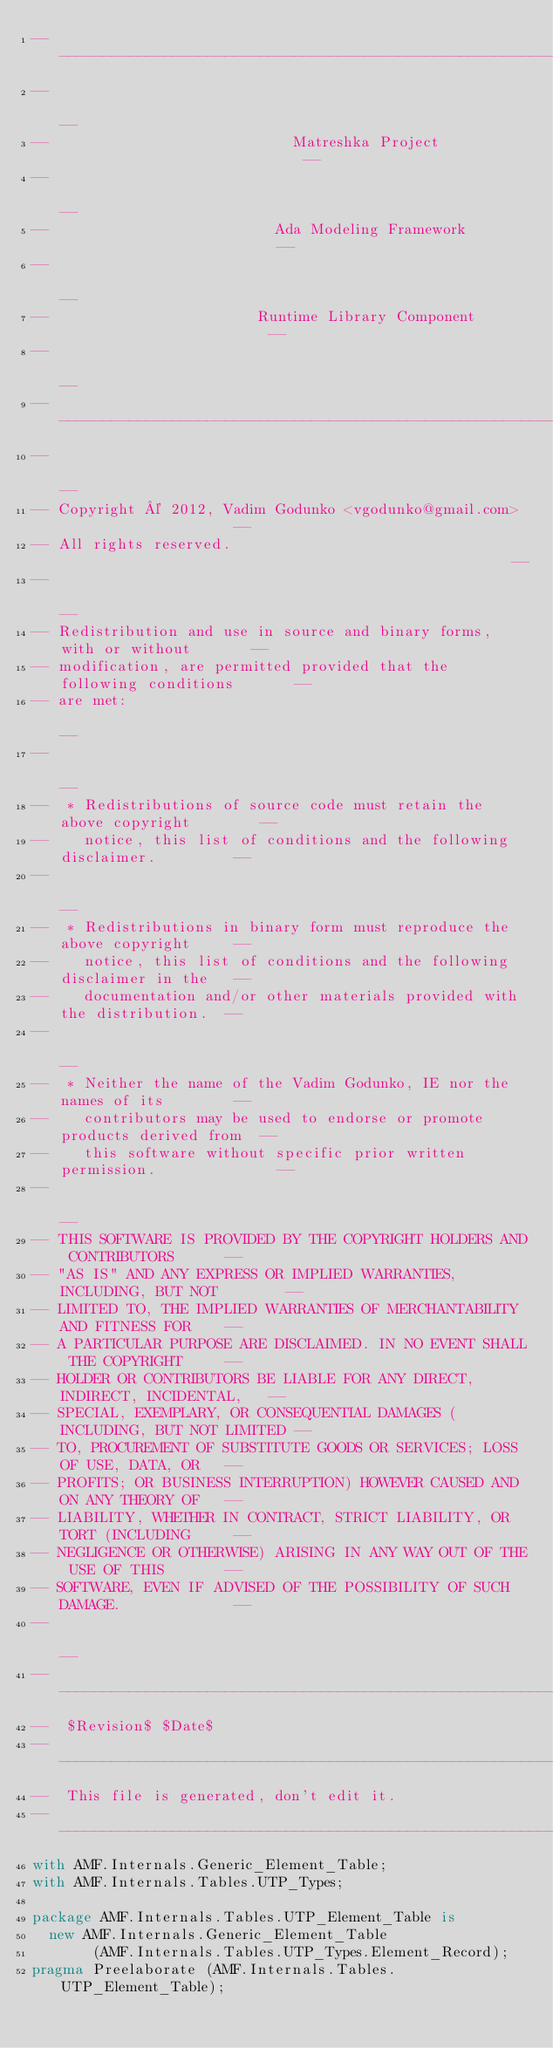Convert code to text. <code><loc_0><loc_0><loc_500><loc_500><_Ada_>------------------------------------------------------------------------------
--                                                                          --
--                            Matreshka Project                             --
--                                                                          --
--                          Ada Modeling Framework                          --
--                                                                          --
--                        Runtime Library Component                         --
--                                                                          --
------------------------------------------------------------------------------
--                                                                          --
-- Copyright © 2012, Vadim Godunko <vgodunko@gmail.com>                     --
-- All rights reserved.                                                     --
--                                                                          --
-- Redistribution and use in source and binary forms, with or without       --
-- modification, are permitted provided that the following conditions       --
-- are met:                                                                 --
--                                                                          --
--  * Redistributions of source code must retain the above copyright        --
--    notice, this list of conditions and the following disclaimer.         --
--                                                                          --
--  * Redistributions in binary form must reproduce the above copyright     --
--    notice, this list of conditions and the following disclaimer in the   --
--    documentation and/or other materials provided with the distribution.  --
--                                                                          --
--  * Neither the name of the Vadim Godunko, IE nor the names of its        --
--    contributors may be used to endorse or promote products derived from  --
--    this software without specific prior written permission.              --
--                                                                          --
-- THIS SOFTWARE IS PROVIDED BY THE COPYRIGHT HOLDERS AND CONTRIBUTORS      --
-- "AS IS" AND ANY EXPRESS OR IMPLIED WARRANTIES, INCLUDING, BUT NOT        --
-- LIMITED TO, THE IMPLIED WARRANTIES OF MERCHANTABILITY AND FITNESS FOR    --
-- A PARTICULAR PURPOSE ARE DISCLAIMED. IN NO EVENT SHALL THE COPYRIGHT     --
-- HOLDER OR CONTRIBUTORS BE LIABLE FOR ANY DIRECT, INDIRECT, INCIDENTAL,   --
-- SPECIAL, EXEMPLARY, OR CONSEQUENTIAL DAMAGES (INCLUDING, BUT NOT LIMITED --
-- TO, PROCUREMENT OF SUBSTITUTE GOODS OR SERVICES; LOSS OF USE, DATA, OR   --
-- PROFITS; OR BUSINESS INTERRUPTION) HOWEVER CAUSED AND ON ANY THEORY OF   --
-- LIABILITY, WHETHER IN CONTRACT, STRICT LIABILITY, OR TORT (INCLUDING     --
-- NEGLIGENCE OR OTHERWISE) ARISING IN ANY WAY OUT OF THE USE OF THIS       --
-- SOFTWARE, EVEN IF ADVISED OF THE POSSIBILITY OF SUCH DAMAGE.             --
--                                                                          --
------------------------------------------------------------------------------
--  $Revision$ $Date$
------------------------------------------------------------------------------
--  This file is generated, don't edit it.
------------------------------------------------------------------------------
with AMF.Internals.Generic_Element_Table;
with AMF.Internals.Tables.UTP_Types;

package AMF.Internals.Tables.UTP_Element_Table is
  new AMF.Internals.Generic_Element_Table
       (AMF.Internals.Tables.UTP_Types.Element_Record);
pragma Preelaborate (AMF.Internals.Tables.UTP_Element_Table);
</code> 